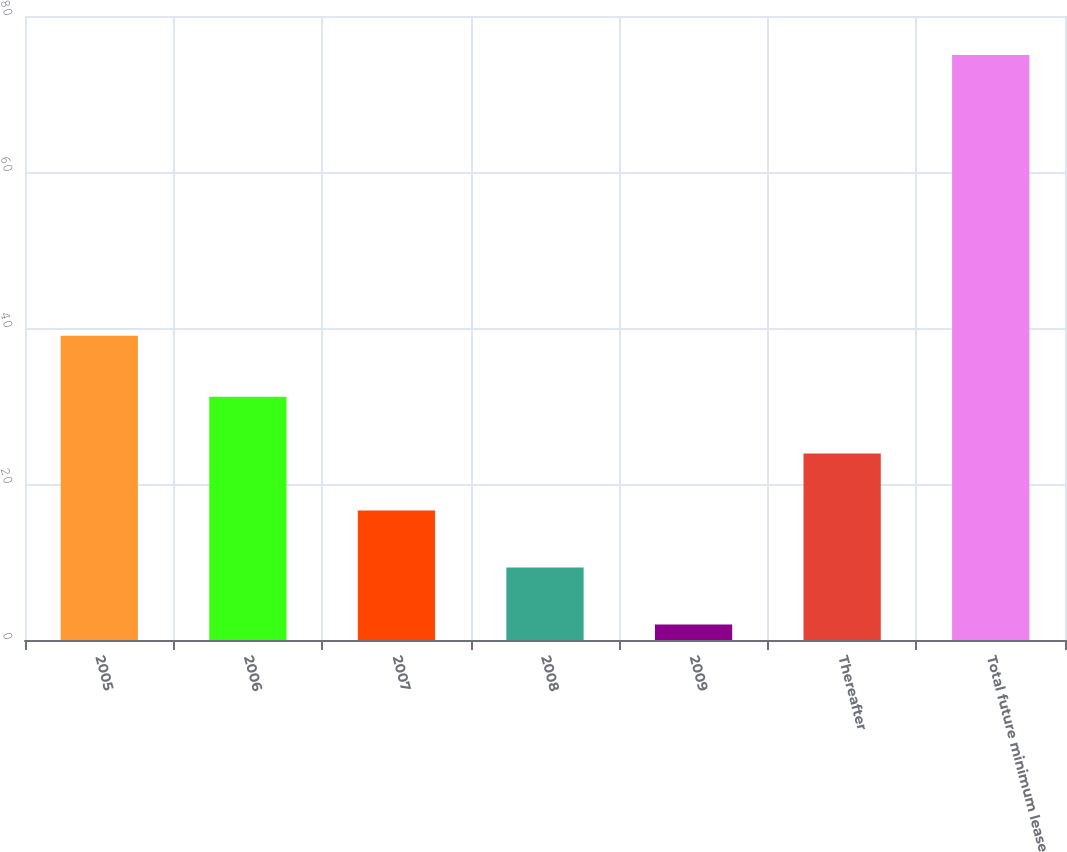Convert chart. <chart><loc_0><loc_0><loc_500><loc_500><bar_chart><fcel>2005<fcel>2006<fcel>2007<fcel>2008<fcel>2009<fcel>Thereafter<fcel>Total future minimum lease<nl><fcel>39<fcel>31.2<fcel>16.6<fcel>9.3<fcel>2<fcel>23.9<fcel>75<nl></chart> 